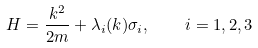Convert formula to latex. <formula><loc_0><loc_0><loc_500><loc_500>H = \frac { k ^ { 2 } } { 2 m } + \lambda _ { i } ( k ) \sigma _ { i } , \quad i = 1 , 2 , 3</formula> 